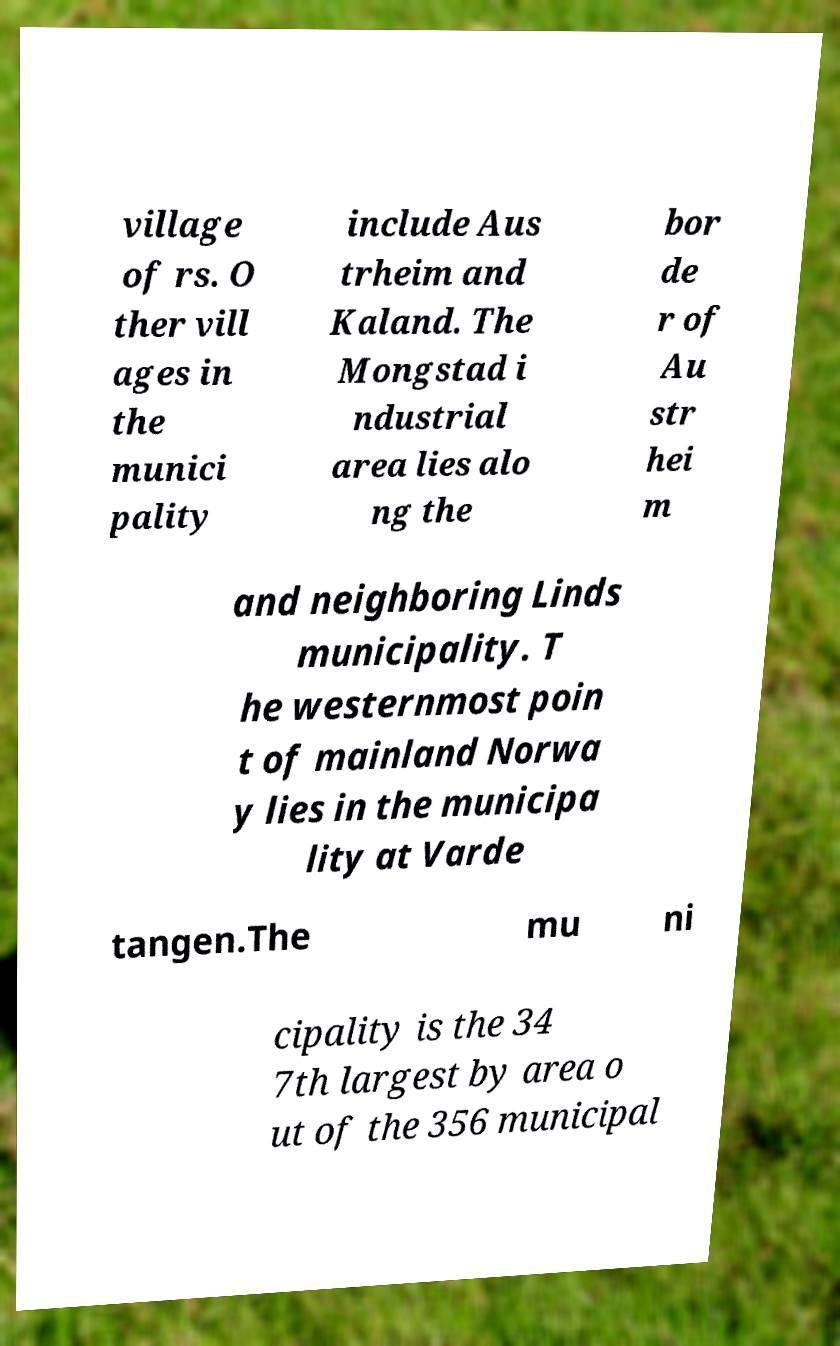Could you extract and type out the text from this image? village of rs. O ther vill ages in the munici pality include Aus trheim and Kaland. The Mongstad i ndustrial area lies alo ng the bor de r of Au str hei m and neighboring Linds municipality. T he westernmost poin t of mainland Norwa y lies in the municipa lity at Varde tangen.The mu ni cipality is the 34 7th largest by area o ut of the 356 municipal 